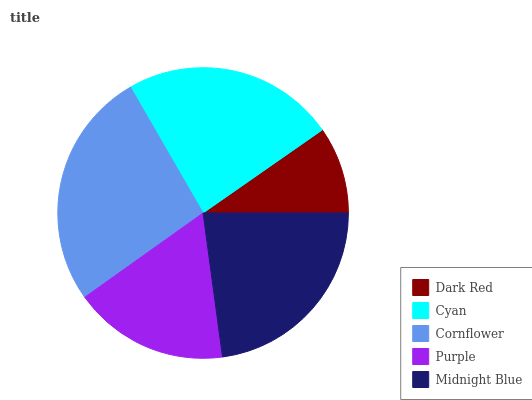Is Dark Red the minimum?
Answer yes or no. Yes. Is Cornflower the maximum?
Answer yes or no. Yes. Is Cyan the minimum?
Answer yes or no. No. Is Cyan the maximum?
Answer yes or no. No. Is Cyan greater than Dark Red?
Answer yes or no. Yes. Is Dark Red less than Cyan?
Answer yes or no. Yes. Is Dark Red greater than Cyan?
Answer yes or no. No. Is Cyan less than Dark Red?
Answer yes or no. No. Is Midnight Blue the high median?
Answer yes or no. Yes. Is Midnight Blue the low median?
Answer yes or no. Yes. Is Cyan the high median?
Answer yes or no. No. Is Purple the low median?
Answer yes or no. No. 